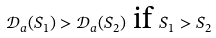Convert formula to latex. <formula><loc_0><loc_0><loc_500><loc_500>\mathcal { D } _ { a } ( S _ { 1 } ) > \mathcal { D } _ { a } ( S _ { 2 } ) \text { if } S _ { 1 } > S _ { 2 }</formula> 